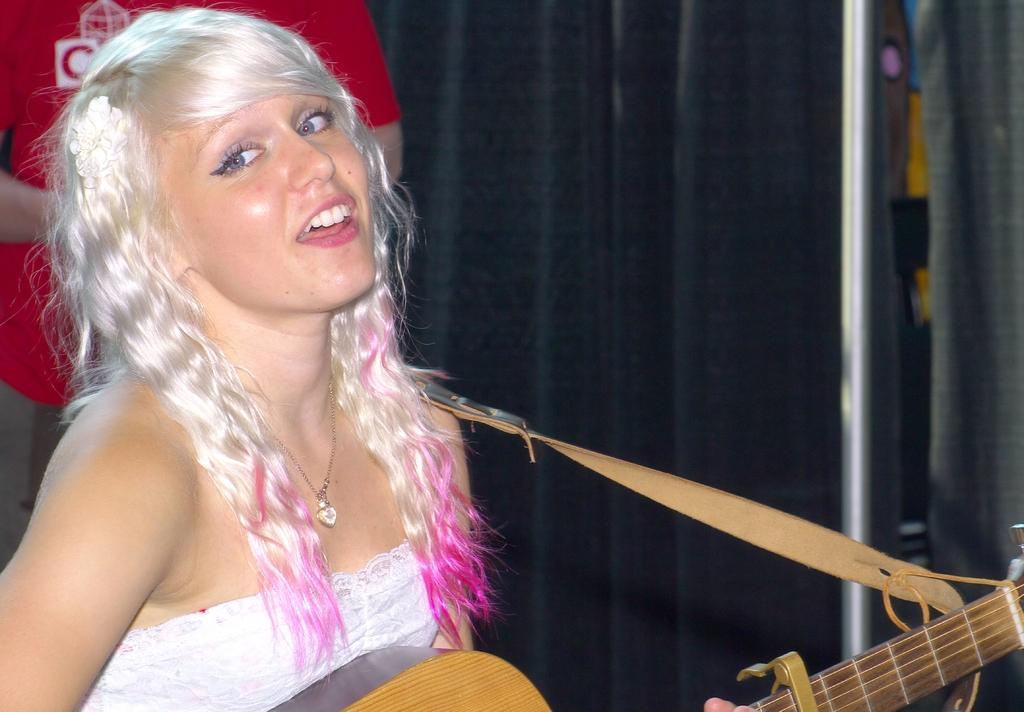Who is the main subject in the image? There is a girl in the image. What is the girl holding in the image? The girl is holding a guitar. What accessory is the girl wearing in the image? The girl is wearing a necklace. What is the girl wearing on her body in the image? The girl is wearing a white dress. Can you describe the presence of another person in the image? There is another person in the background of the image. What type of expansion is visible in the image? There is no expansion visible in the image. What is the slope of the ground in the image? There is no slope visible in the image; it appears to be a flat surface. 